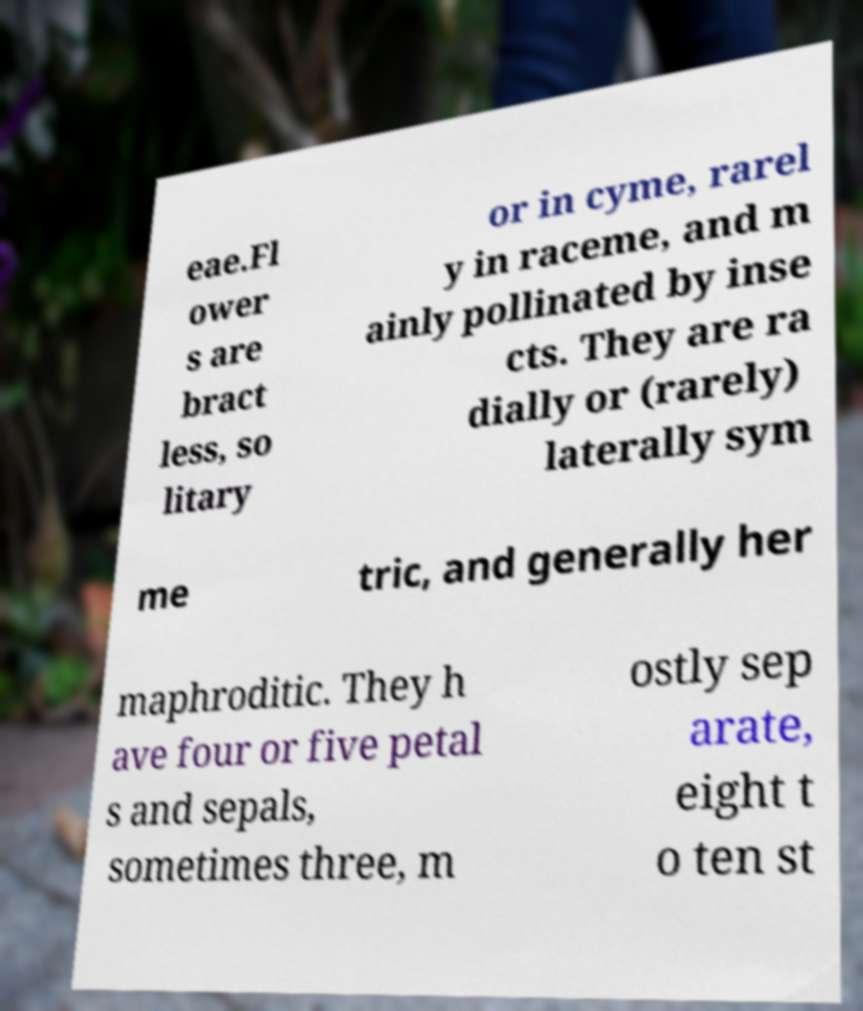For documentation purposes, I need the text within this image transcribed. Could you provide that? eae.Fl ower s are bract less, so litary or in cyme, rarel y in raceme, and m ainly pollinated by inse cts. They are ra dially or (rarely) laterally sym me tric, and generally her maphroditic. They h ave four or five petal s and sepals, sometimes three, m ostly sep arate, eight t o ten st 